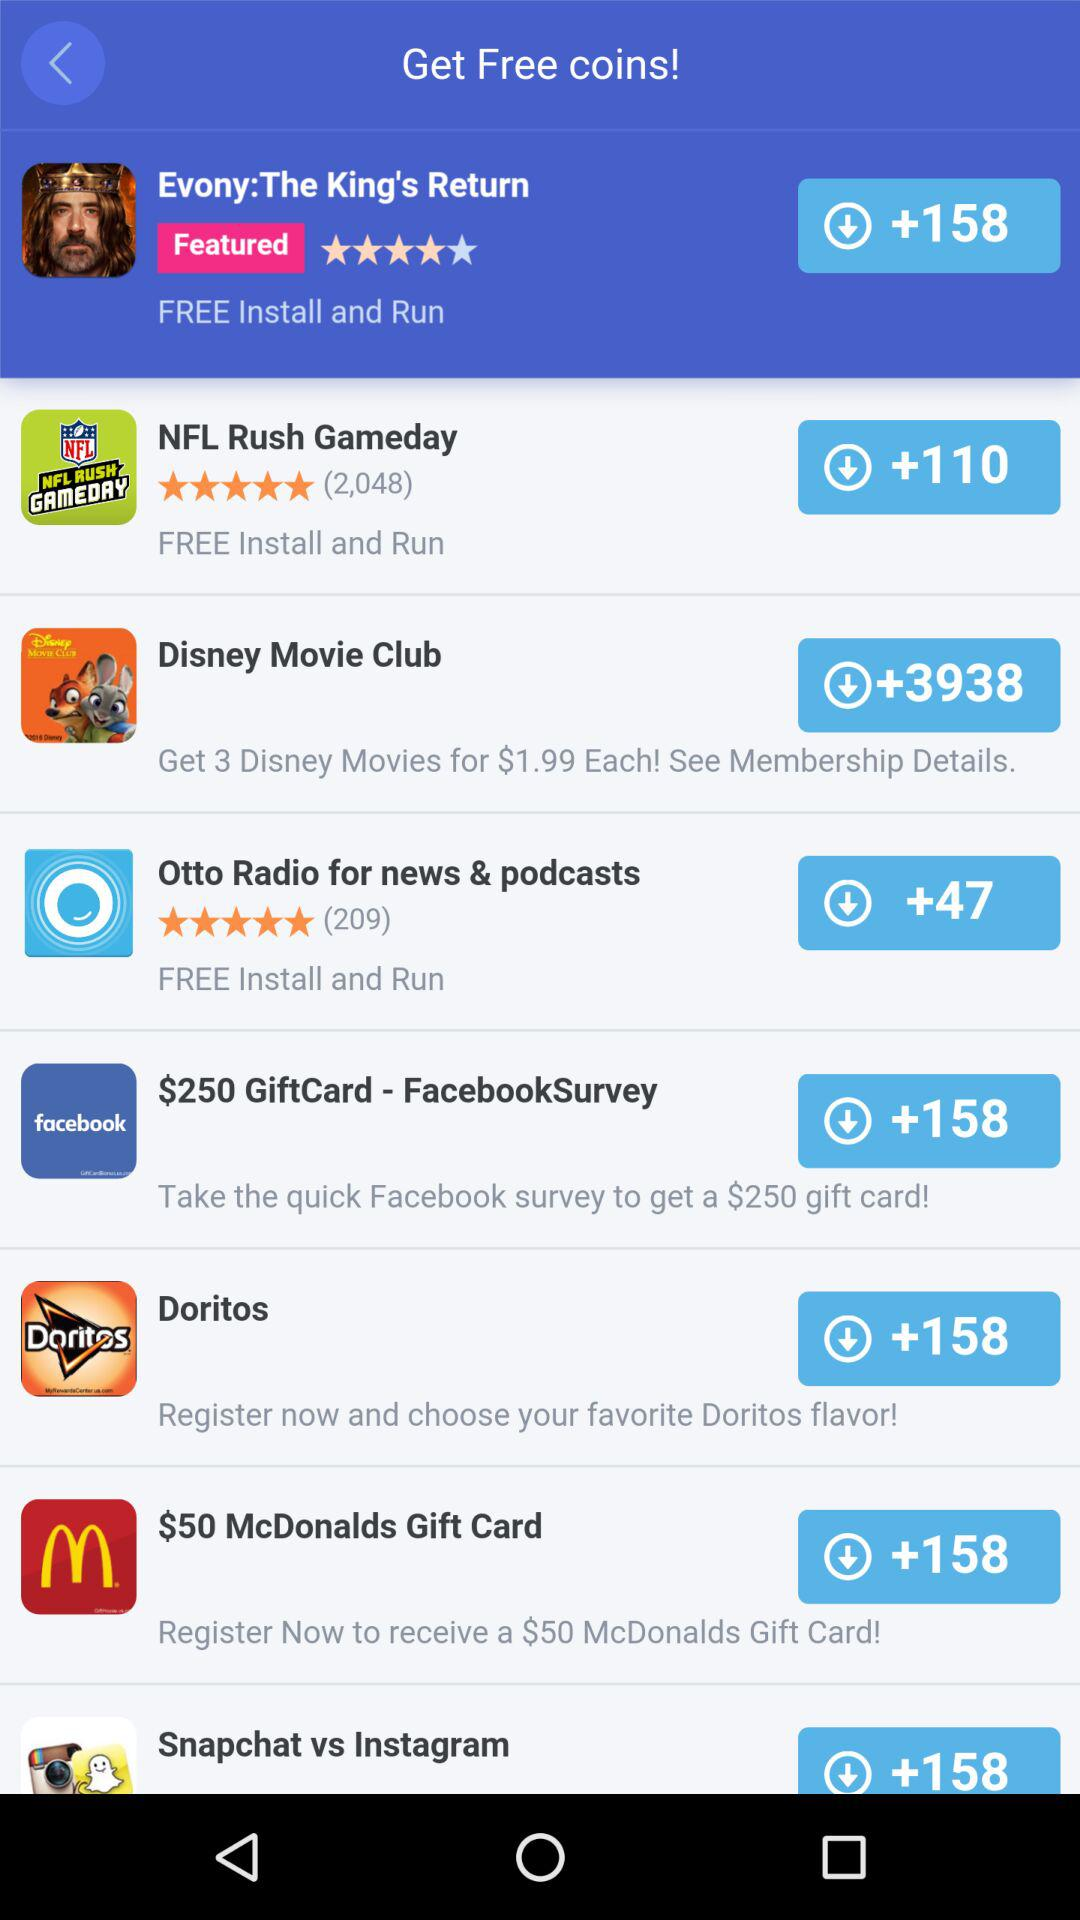What is the rating of "NFL"? The rating is 5 stars. 